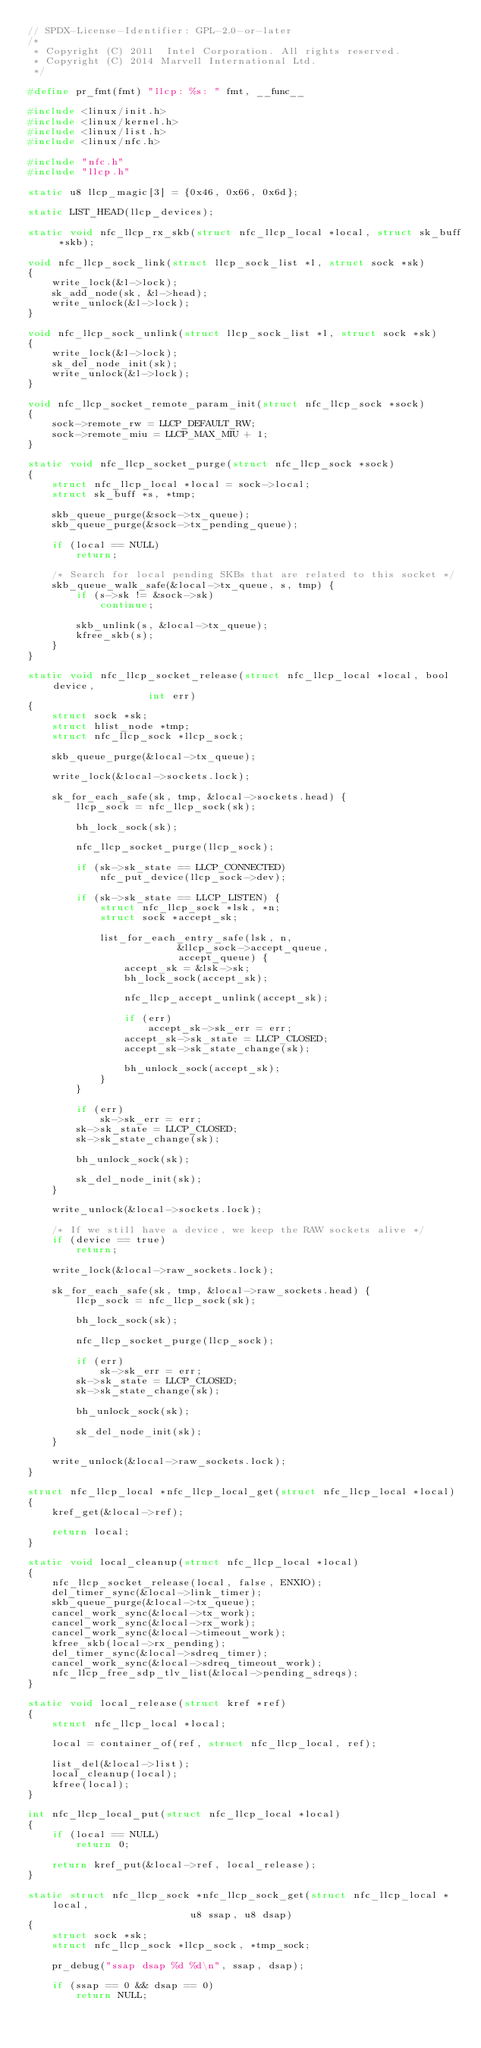<code> <loc_0><loc_0><loc_500><loc_500><_C_>// SPDX-License-Identifier: GPL-2.0-or-later
/*
 * Copyright (C) 2011  Intel Corporation. All rights reserved.
 * Copyright (C) 2014 Marvell International Ltd.
 */

#define pr_fmt(fmt) "llcp: %s: " fmt, __func__

#include <linux/init.h>
#include <linux/kernel.h>
#include <linux/list.h>
#include <linux/nfc.h>

#include "nfc.h"
#include "llcp.h"

static u8 llcp_magic[3] = {0x46, 0x66, 0x6d};

static LIST_HEAD(llcp_devices);

static void nfc_llcp_rx_skb(struct nfc_llcp_local *local, struct sk_buff *skb);

void nfc_llcp_sock_link(struct llcp_sock_list *l, struct sock *sk)
{
	write_lock(&l->lock);
	sk_add_node(sk, &l->head);
	write_unlock(&l->lock);
}

void nfc_llcp_sock_unlink(struct llcp_sock_list *l, struct sock *sk)
{
	write_lock(&l->lock);
	sk_del_node_init(sk);
	write_unlock(&l->lock);
}

void nfc_llcp_socket_remote_param_init(struct nfc_llcp_sock *sock)
{
	sock->remote_rw = LLCP_DEFAULT_RW;
	sock->remote_miu = LLCP_MAX_MIU + 1;
}

static void nfc_llcp_socket_purge(struct nfc_llcp_sock *sock)
{
	struct nfc_llcp_local *local = sock->local;
	struct sk_buff *s, *tmp;

	skb_queue_purge(&sock->tx_queue);
	skb_queue_purge(&sock->tx_pending_queue);

	if (local == NULL)
		return;

	/* Search for local pending SKBs that are related to this socket */
	skb_queue_walk_safe(&local->tx_queue, s, tmp) {
		if (s->sk != &sock->sk)
			continue;

		skb_unlink(s, &local->tx_queue);
		kfree_skb(s);
	}
}

static void nfc_llcp_socket_release(struct nfc_llcp_local *local, bool device,
				    int err)
{
	struct sock *sk;
	struct hlist_node *tmp;
	struct nfc_llcp_sock *llcp_sock;

	skb_queue_purge(&local->tx_queue);

	write_lock(&local->sockets.lock);

	sk_for_each_safe(sk, tmp, &local->sockets.head) {
		llcp_sock = nfc_llcp_sock(sk);

		bh_lock_sock(sk);

		nfc_llcp_socket_purge(llcp_sock);

		if (sk->sk_state == LLCP_CONNECTED)
			nfc_put_device(llcp_sock->dev);

		if (sk->sk_state == LLCP_LISTEN) {
			struct nfc_llcp_sock *lsk, *n;
			struct sock *accept_sk;

			list_for_each_entry_safe(lsk, n,
						 &llcp_sock->accept_queue,
						 accept_queue) {
				accept_sk = &lsk->sk;
				bh_lock_sock(accept_sk);

				nfc_llcp_accept_unlink(accept_sk);

				if (err)
					accept_sk->sk_err = err;
				accept_sk->sk_state = LLCP_CLOSED;
				accept_sk->sk_state_change(sk);

				bh_unlock_sock(accept_sk);
			}
		}

		if (err)
			sk->sk_err = err;
		sk->sk_state = LLCP_CLOSED;
		sk->sk_state_change(sk);

		bh_unlock_sock(sk);

		sk_del_node_init(sk);
	}

	write_unlock(&local->sockets.lock);

	/* If we still have a device, we keep the RAW sockets alive */
	if (device == true)
		return;

	write_lock(&local->raw_sockets.lock);

	sk_for_each_safe(sk, tmp, &local->raw_sockets.head) {
		llcp_sock = nfc_llcp_sock(sk);

		bh_lock_sock(sk);

		nfc_llcp_socket_purge(llcp_sock);

		if (err)
			sk->sk_err = err;
		sk->sk_state = LLCP_CLOSED;
		sk->sk_state_change(sk);

		bh_unlock_sock(sk);

		sk_del_node_init(sk);
	}

	write_unlock(&local->raw_sockets.lock);
}

struct nfc_llcp_local *nfc_llcp_local_get(struct nfc_llcp_local *local)
{
	kref_get(&local->ref);

	return local;
}

static void local_cleanup(struct nfc_llcp_local *local)
{
	nfc_llcp_socket_release(local, false, ENXIO);
	del_timer_sync(&local->link_timer);
	skb_queue_purge(&local->tx_queue);
	cancel_work_sync(&local->tx_work);
	cancel_work_sync(&local->rx_work);
	cancel_work_sync(&local->timeout_work);
	kfree_skb(local->rx_pending);
	del_timer_sync(&local->sdreq_timer);
	cancel_work_sync(&local->sdreq_timeout_work);
	nfc_llcp_free_sdp_tlv_list(&local->pending_sdreqs);
}

static void local_release(struct kref *ref)
{
	struct nfc_llcp_local *local;

	local = container_of(ref, struct nfc_llcp_local, ref);

	list_del(&local->list);
	local_cleanup(local);
	kfree(local);
}

int nfc_llcp_local_put(struct nfc_llcp_local *local)
{
	if (local == NULL)
		return 0;

	return kref_put(&local->ref, local_release);
}

static struct nfc_llcp_sock *nfc_llcp_sock_get(struct nfc_llcp_local *local,
					       u8 ssap, u8 dsap)
{
	struct sock *sk;
	struct nfc_llcp_sock *llcp_sock, *tmp_sock;

	pr_debug("ssap dsap %d %d\n", ssap, dsap);

	if (ssap == 0 && dsap == 0)
		return NULL;
</code> 